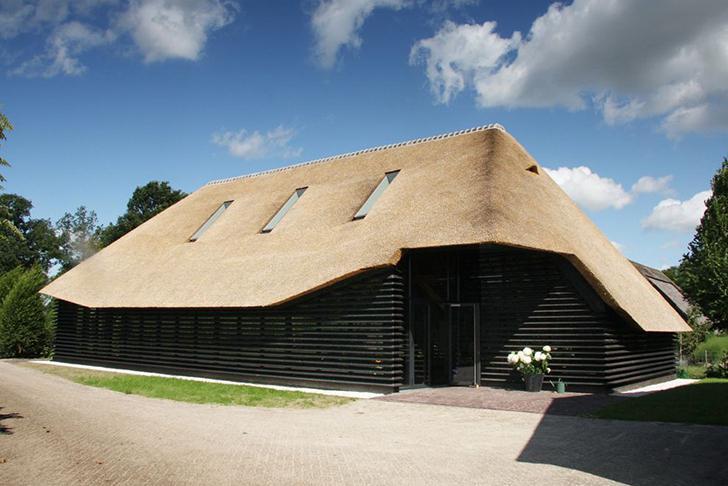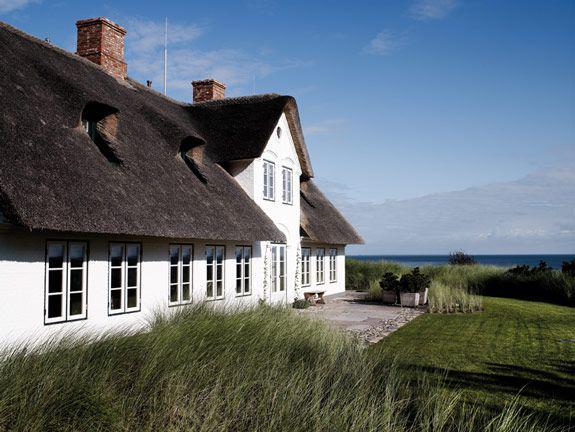The first image is the image on the left, the second image is the image on the right. For the images displayed, is the sentence "One of the houses has at least one chimney." factually correct? Answer yes or no. Yes. 